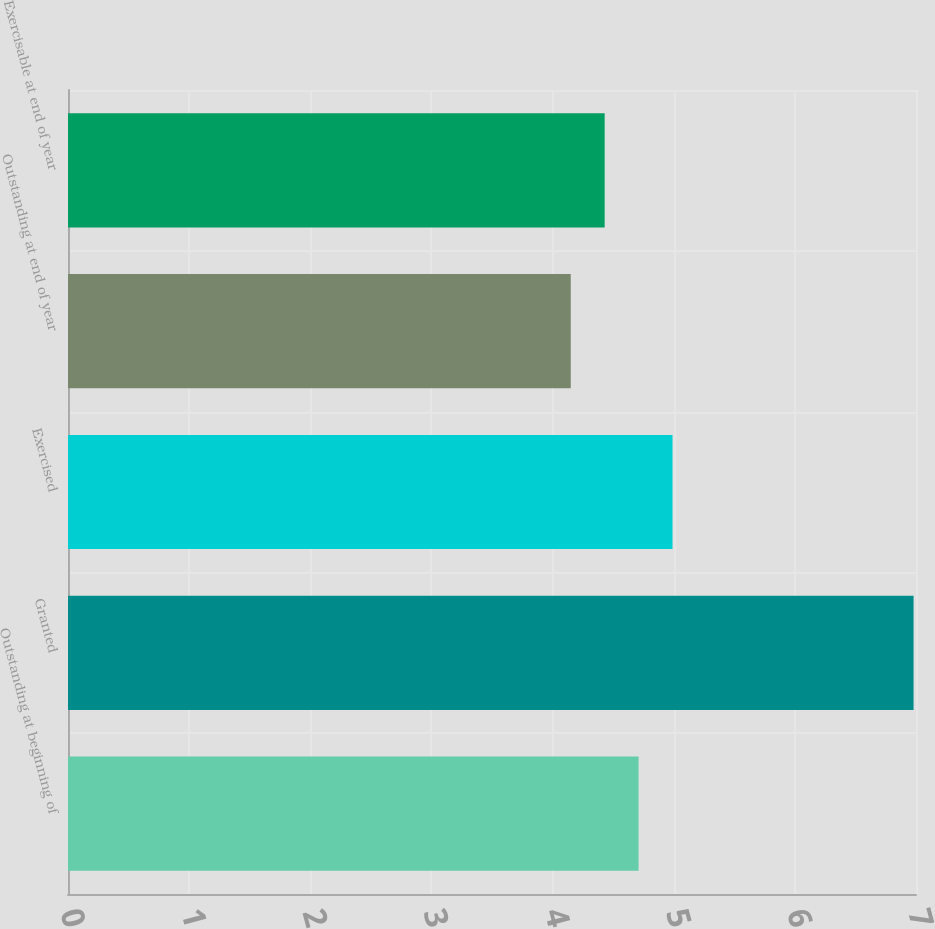Convert chart to OTSL. <chart><loc_0><loc_0><loc_500><loc_500><bar_chart><fcel>Outstanding at beginning of<fcel>Granted<fcel>Exercised<fcel>Outstanding at end of year<fcel>Exercisable at end of year<nl><fcel>4.71<fcel>6.98<fcel>4.99<fcel>4.15<fcel>4.43<nl></chart> 